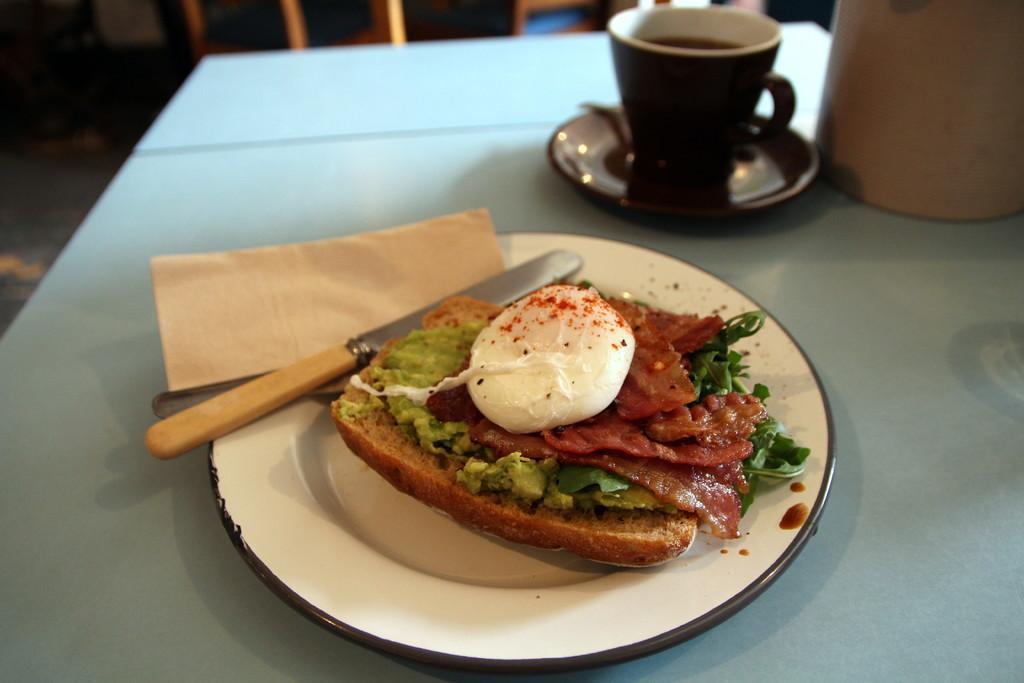Can you describe this image briefly? The picture consists of a blue table on which a plate and cups and saucer are present, where on the plate there is sandwich and knife are present. 